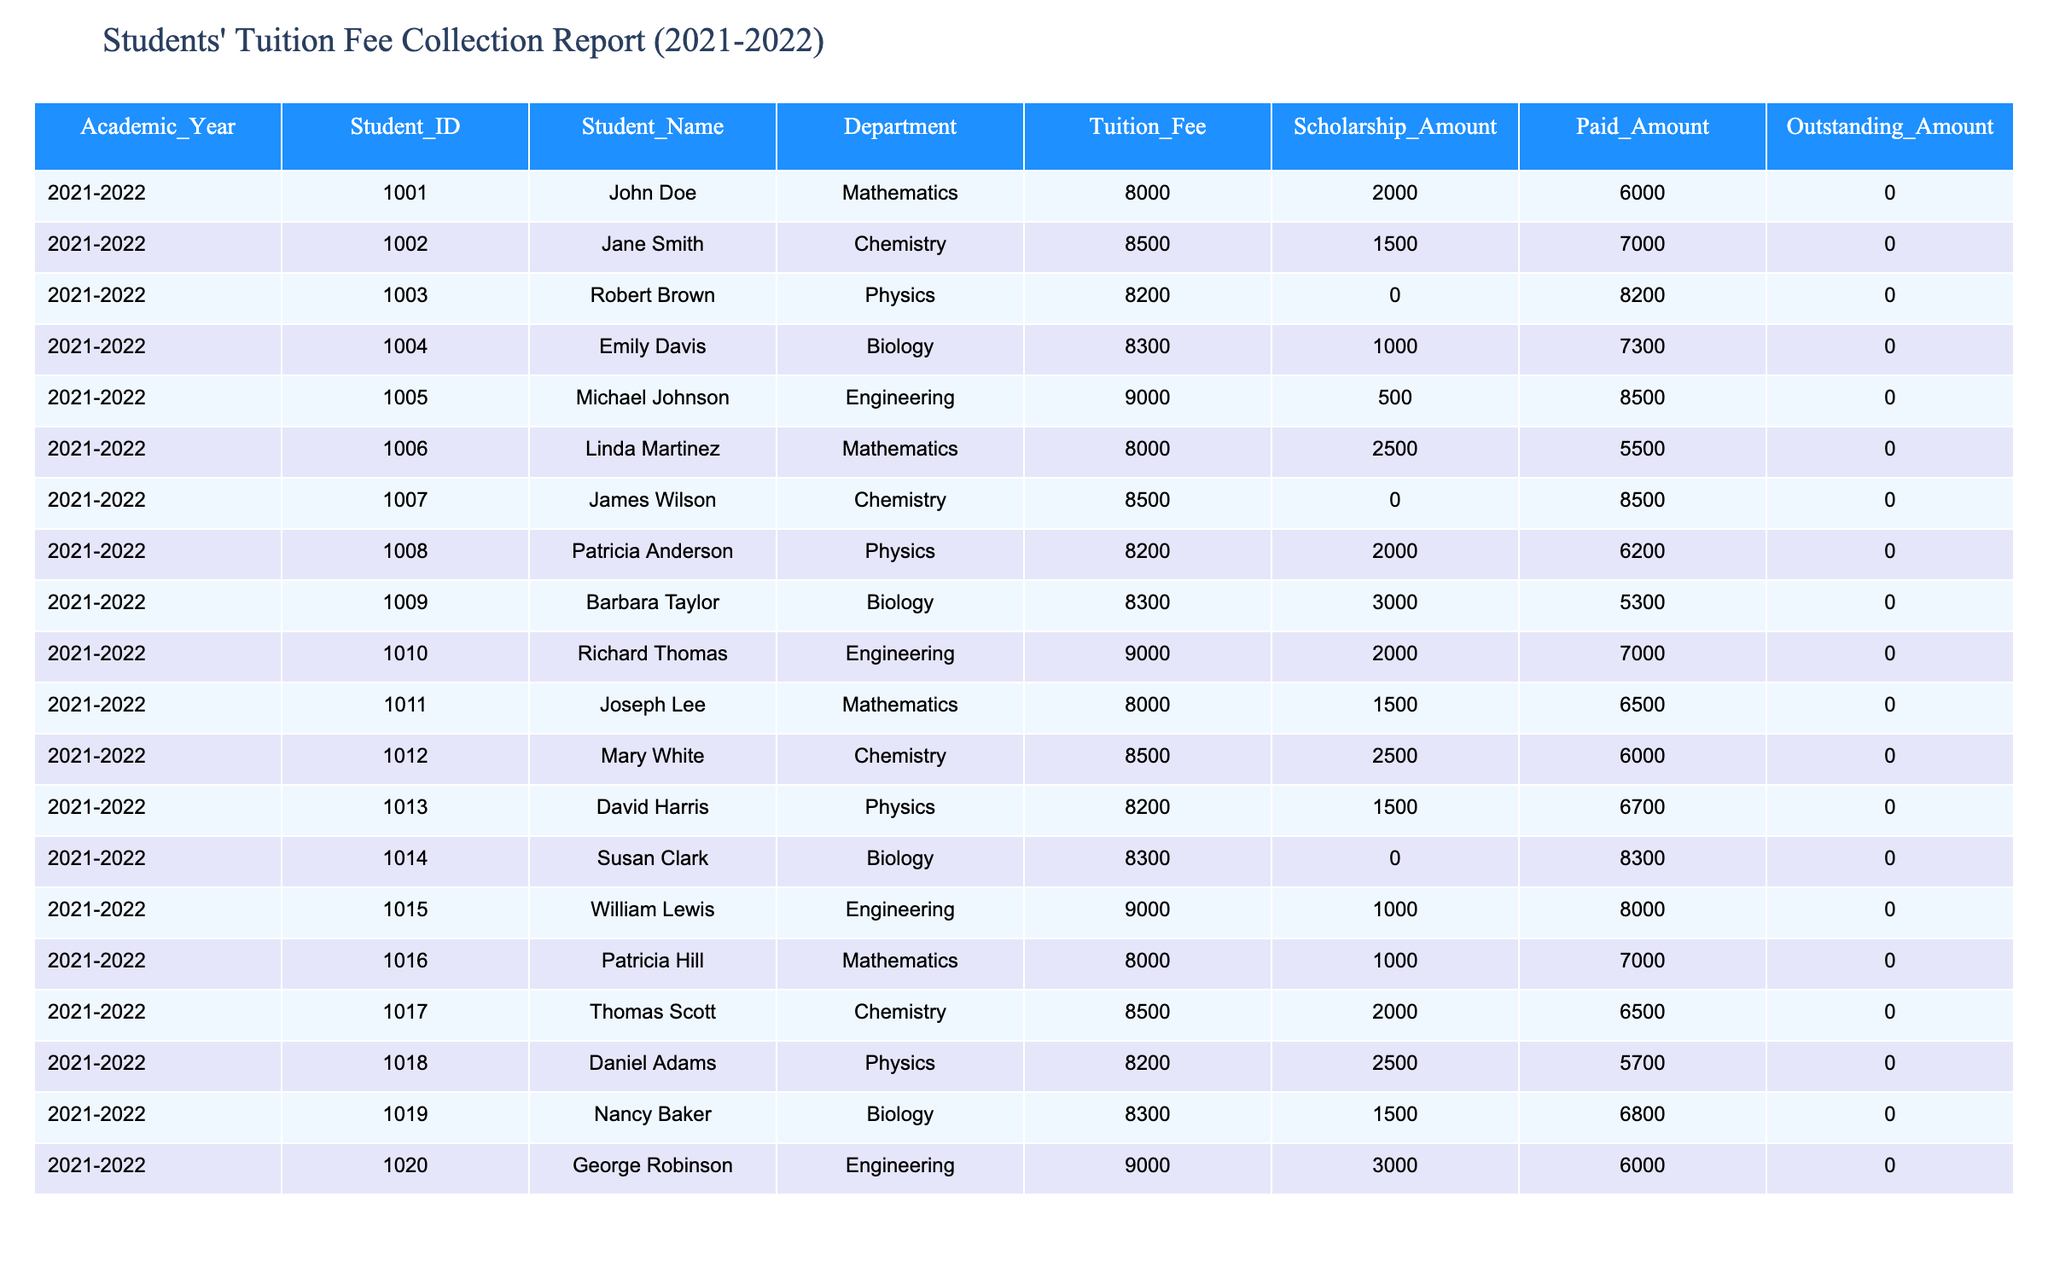What is the total amount of Tuition Fees collected from all students? To find the total Tuition Fees, we sum up the Tuition Fee column. Adding them up: 8000 + 8500 + 8200 + 8300 + 9000 + 8000 + 8500 + 8200 + 8300 + 9000 + 8000 + 8500 + 8200 + 8300 + 9000 + 8000 + 8500 + 8200 + 8300 + 9000 = 164000.
Answer: 164000 How much total Scholarship Amount is provided to students? To find the total Scholarship Amount, we sum up the Scholarship Amount column. Adding them up: 2000 + 1500 + 0 + 1000 + 500 + 2500 + 0 + 2000 + 3000 + 2000 + 1500 + 2500 + 1500 + 0 + 1000 + 1000 + 2000 + 2500 + 1500 + 3000 = 22000.
Answer: 22000 Is there any student whose Outstanding Amount is greater than 0? All students have an Outstanding Amount of 0, as indicated in the table. Therefore, there are no students with an Outstanding Amount greater than 0.
Answer: No What is the average Paid Amount by all students? To calculate the average Paid Amount, sum all the Paid Amount values: 6000 + 7000 + 8200 + 7300 + 8500 + 5500 + 8500 + 6200 + 5300 + 7000 + 6500 + 6000 + 6700 + 8300 + 8000 + 7000 + 6500 + 5700 + 6800 + 6000 = 126000. Since there are 20 students, the average is 126000 / 20 = 6300.
Answer: 6300 How many students in the Engineering department received a scholarship? We look at the Engineering department students and check the Scholarship Amount. The students are Michael Johnson (500), Richard Thomas (2000), William Lewis (1000), and George Robinson (3000). Out of these, all four received a scholarship, totaling four students.
Answer: 4 What is the total Outstanding Amount for students in the Mathematics department? The Mathematics department has the following students: John Doe (0), Linda Martinez (0), Joseph Lee (0), Patricia Hill (0). All these students have an Outstanding Amount of 0. Therefore, the total Outstanding Amount for Mathematics students is 0.
Answer: 0 